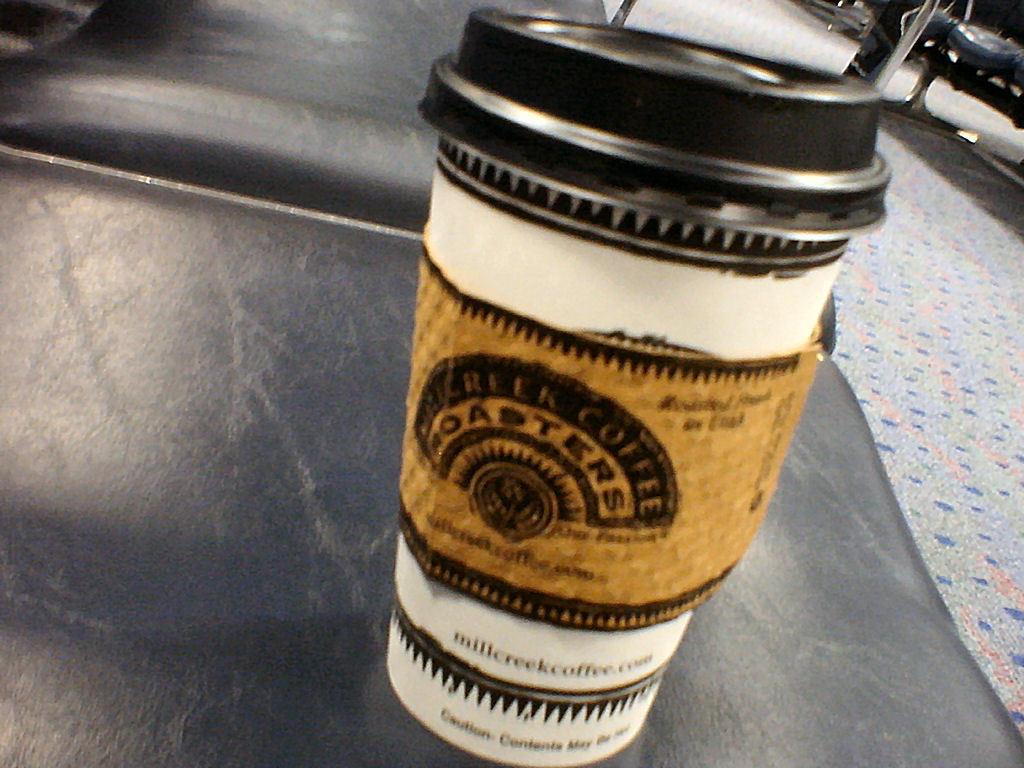Where is this coffee from?
Your answer should be very brief. Mill creek. 